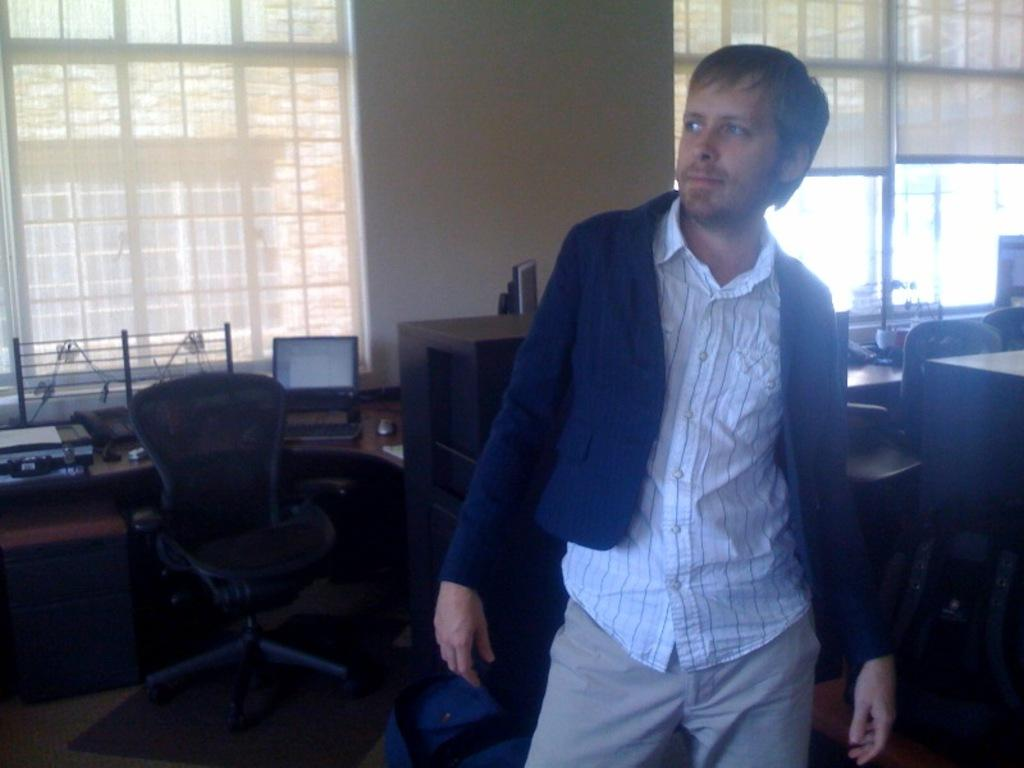What is the primary subject in the image? There is a person standing in the image. What can be seen in the background of the image? There are chairs, a laptop, a wall, windows, and window blinds visible in the background of the image. How are the windows covered in the image? Window blinds are present in the image. What type of corn is being served on the table in the image? There is no table or corn present in the image. What message of peace is being conveyed in the image? There is no message of peace or any reference to peace in the image. 